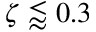Convert formula to latex. <formula><loc_0><loc_0><loc_500><loc_500>\zeta \lessapprox 0 . 3</formula> 